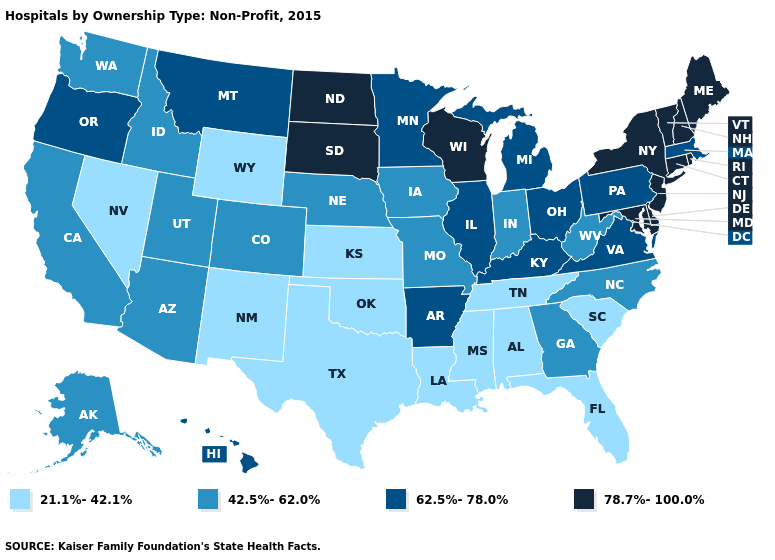Is the legend a continuous bar?
Be succinct. No. Does Pennsylvania have the highest value in the Northeast?
Concise answer only. No. Name the states that have a value in the range 62.5%-78.0%?
Give a very brief answer. Arkansas, Hawaii, Illinois, Kentucky, Massachusetts, Michigan, Minnesota, Montana, Ohio, Oregon, Pennsylvania, Virginia. Does Virginia have the same value as Oregon?
Keep it brief. Yes. How many symbols are there in the legend?
Quick response, please. 4. What is the value of Ohio?
Be succinct. 62.5%-78.0%. Does South Dakota have the same value as Vermont?
Short answer required. Yes. Does Vermont have a higher value than Maine?
Short answer required. No. Which states have the highest value in the USA?
Keep it brief. Connecticut, Delaware, Maine, Maryland, New Hampshire, New Jersey, New York, North Dakota, Rhode Island, South Dakota, Vermont, Wisconsin. How many symbols are there in the legend?
Write a very short answer. 4. Does Hawaii have the highest value in the West?
Be succinct. Yes. Name the states that have a value in the range 62.5%-78.0%?
Short answer required. Arkansas, Hawaii, Illinois, Kentucky, Massachusetts, Michigan, Minnesota, Montana, Ohio, Oregon, Pennsylvania, Virginia. What is the lowest value in states that border Wyoming?
Short answer required. 42.5%-62.0%. Does the first symbol in the legend represent the smallest category?
Be succinct. Yes. Among the states that border Wyoming , which have the highest value?
Be succinct. South Dakota. 